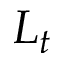Convert formula to latex. <formula><loc_0><loc_0><loc_500><loc_500>L _ { t }</formula> 